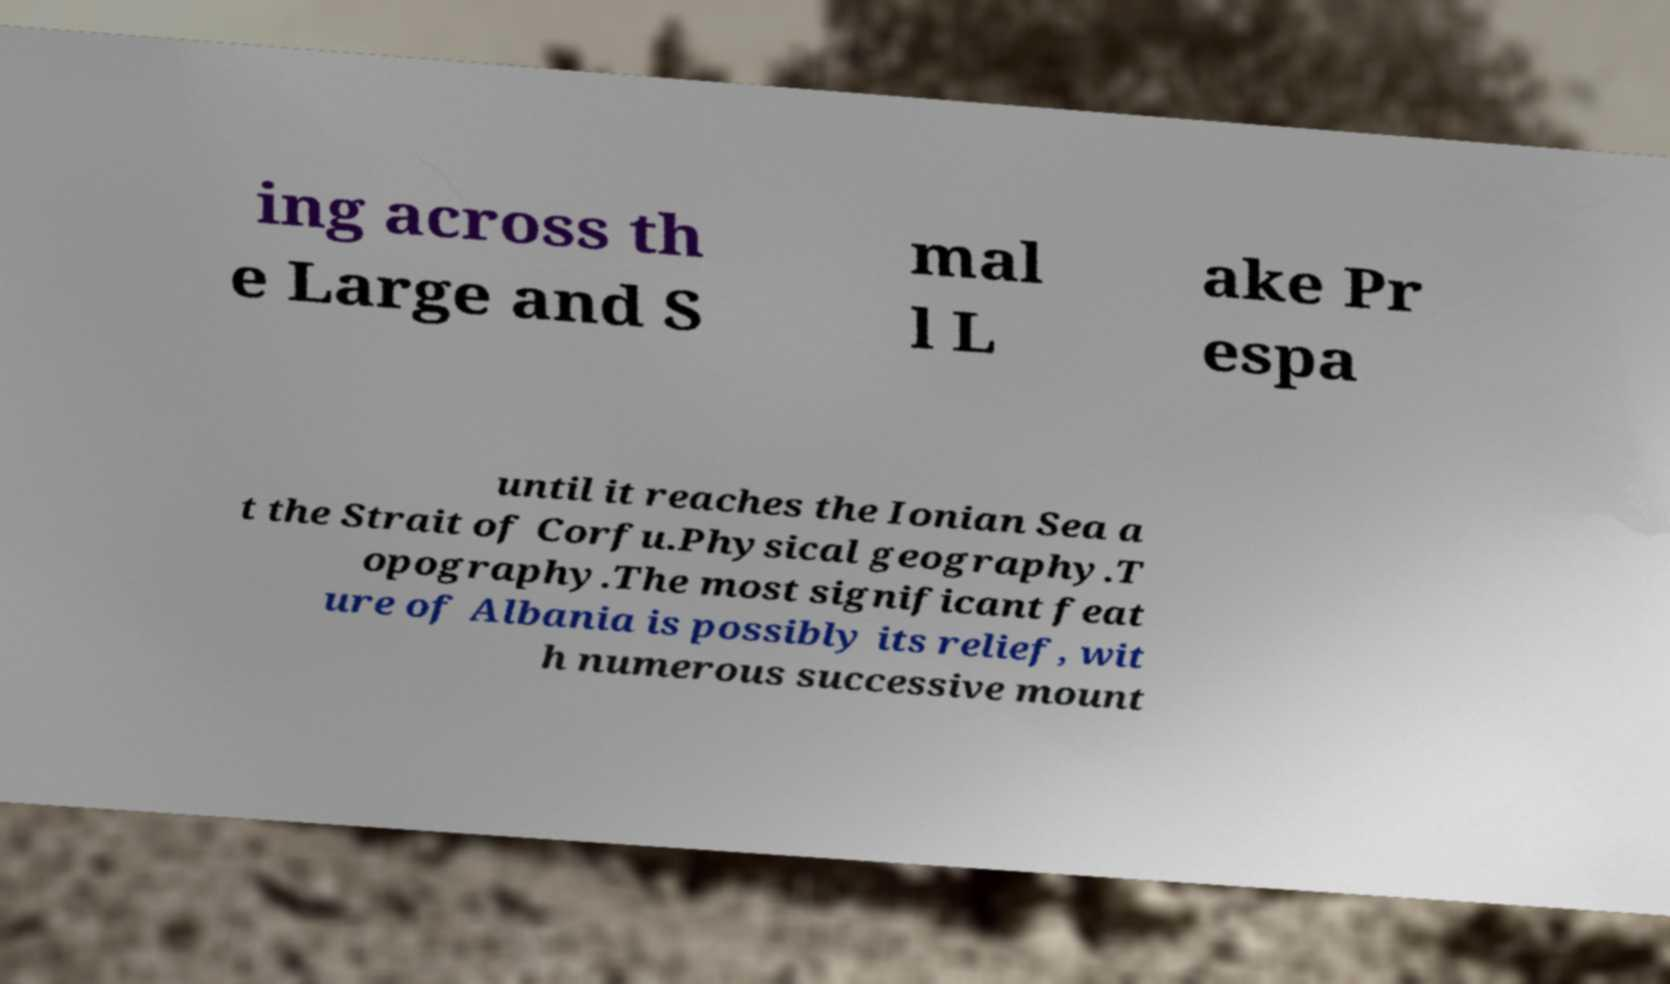I need the written content from this picture converted into text. Can you do that? ing across th e Large and S mal l L ake Pr espa until it reaches the Ionian Sea a t the Strait of Corfu.Physical geography.T opography.The most significant feat ure of Albania is possibly its relief, wit h numerous successive mount 